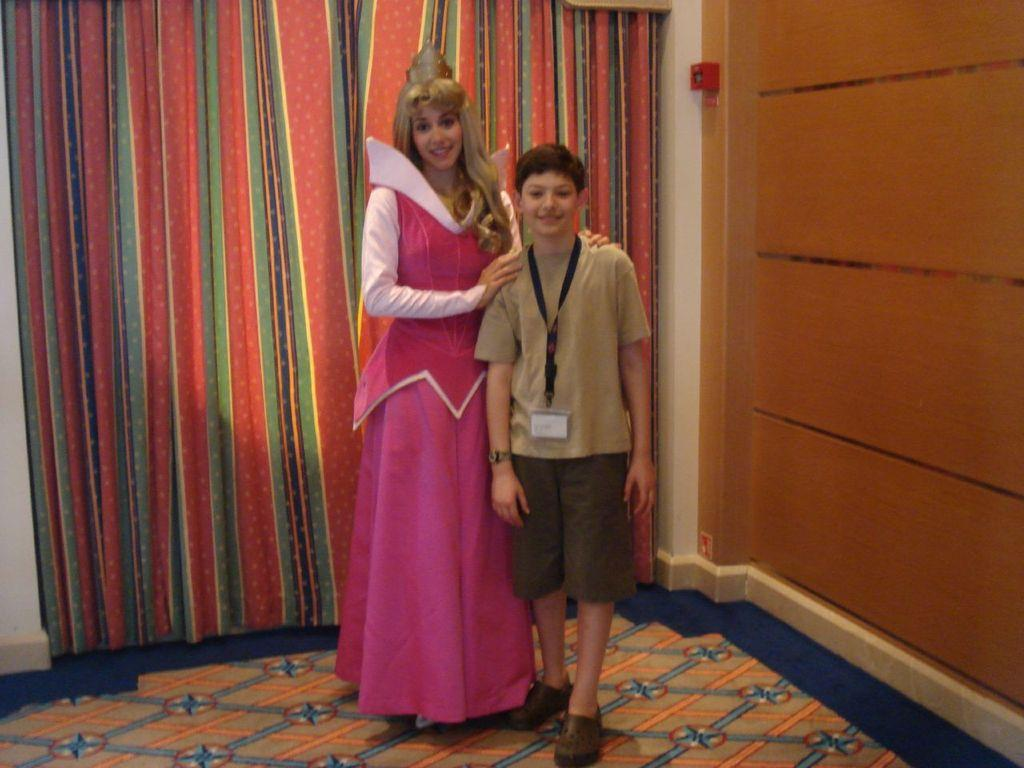Who are the people in the image? There is a woman and a boy in the image. What are the woman and the boy doing in the image? Both the woman and the boy are standing on the floor. What can be seen in the background of the image? There are curtains and a box on the wall in the background of the image. What type of decision can be seen hanging from the woman's ear in the image? There is no decision or any object hanging from the woman's ear in the image. 